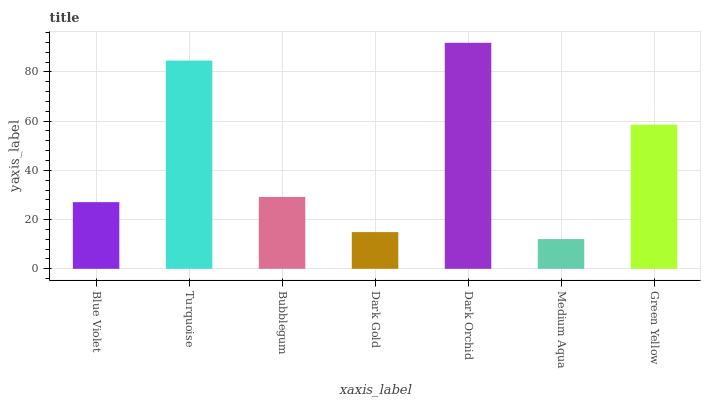Is Medium Aqua the minimum?
Answer yes or no. Yes. Is Dark Orchid the maximum?
Answer yes or no. Yes. Is Turquoise the minimum?
Answer yes or no. No. Is Turquoise the maximum?
Answer yes or no. No. Is Turquoise greater than Blue Violet?
Answer yes or no. Yes. Is Blue Violet less than Turquoise?
Answer yes or no. Yes. Is Blue Violet greater than Turquoise?
Answer yes or no. No. Is Turquoise less than Blue Violet?
Answer yes or no. No. Is Bubblegum the high median?
Answer yes or no. Yes. Is Bubblegum the low median?
Answer yes or no. Yes. Is Medium Aqua the high median?
Answer yes or no. No. Is Dark Gold the low median?
Answer yes or no. No. 